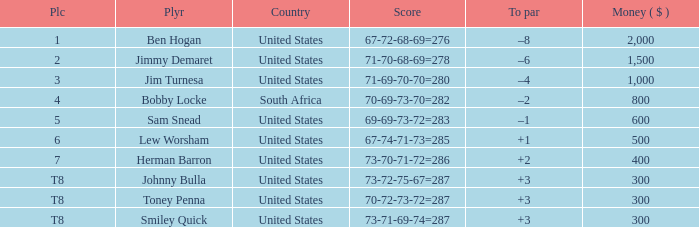What is the Money of the Player in Place 5? 600.0. 